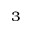Convert formula to latex. <formula><loc_0><loc_0><loc_500><loc_500>^ { 3 }</formula> 